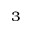Convert formula to latex. <formula><loc_0><loc_0><loc_500><loc_500>^ { 3 }</formula> 